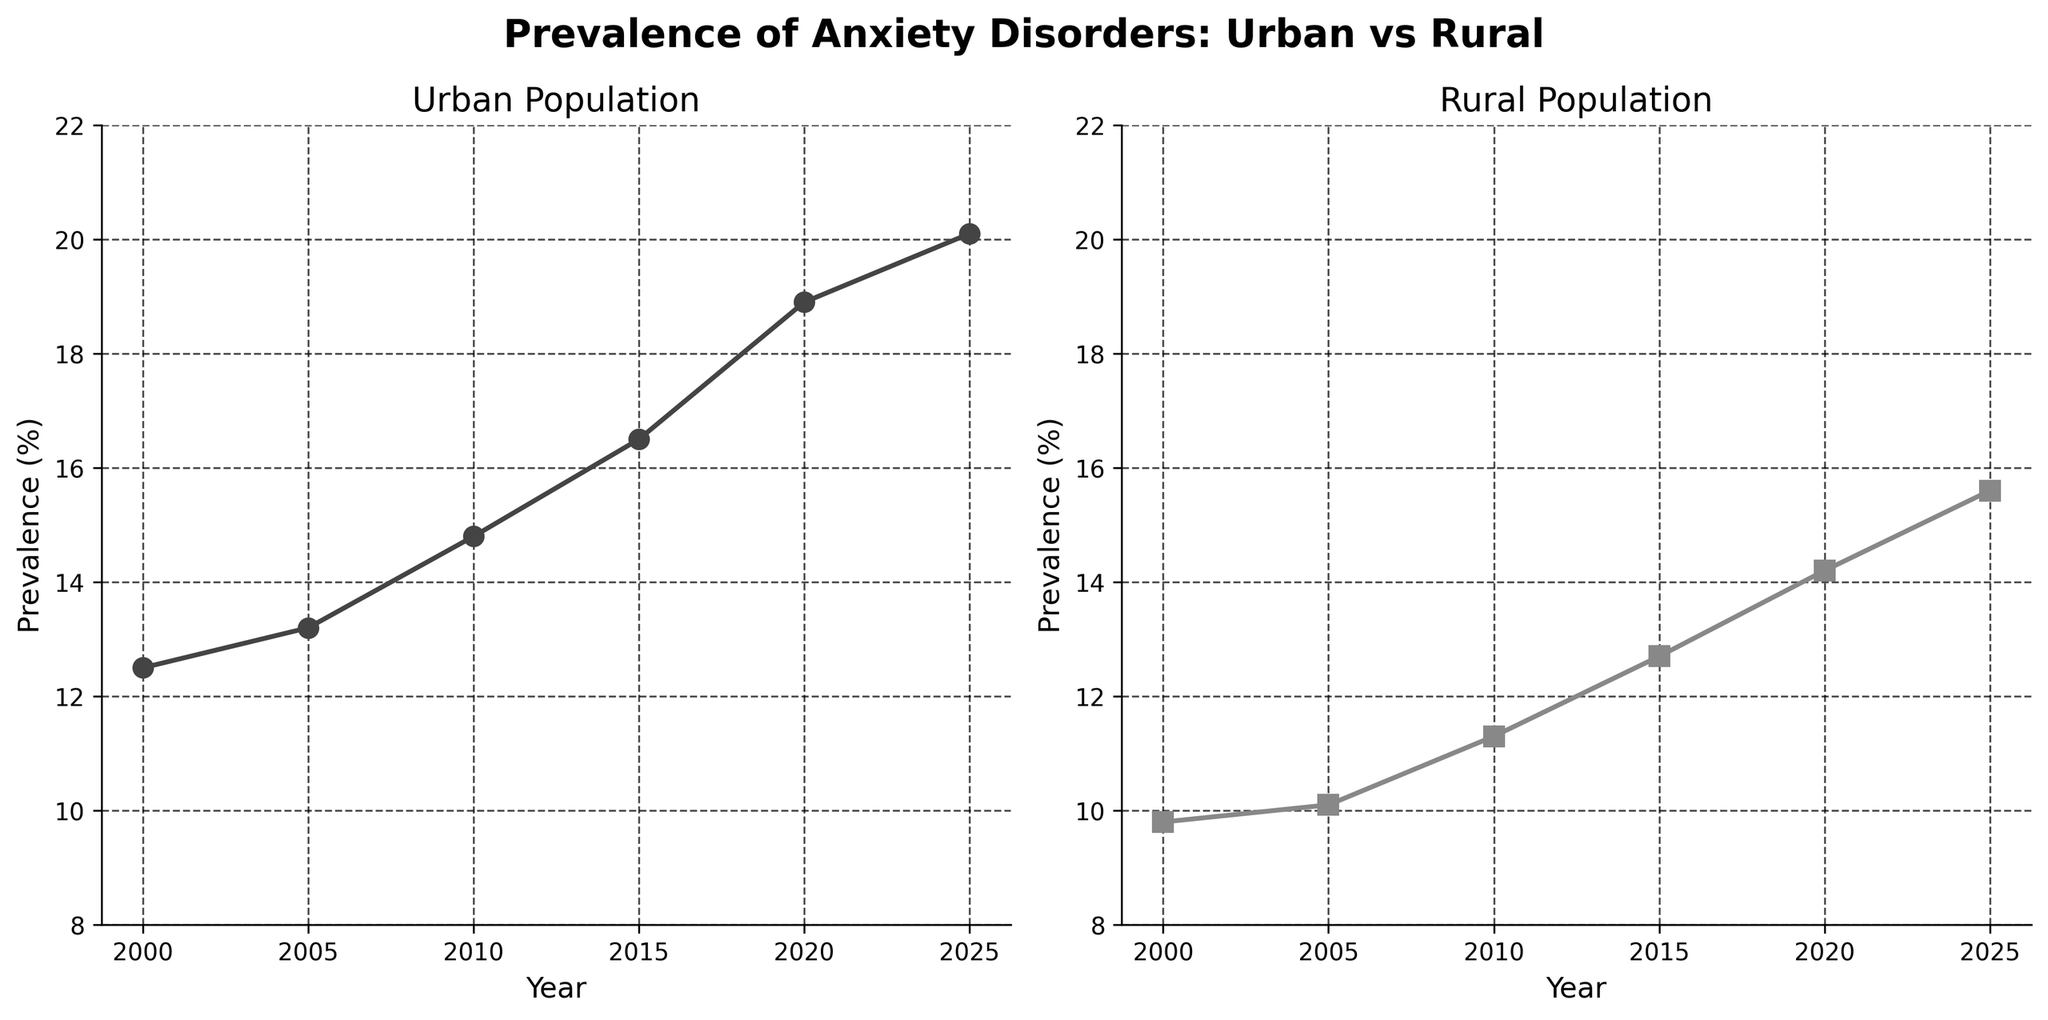What is the title of the figure? The title of the figure is found at the top center of the plot. It reads "Prevalence of Anxiety Disorders: Urban vs Rural".
Answer: Prevalence of Anxiety Disorders: Urban vs Rural What are the x-axis labels in both subplots? The x-axis labels are found at the bottom of each subplot and both read "Year".
Answer: Year Which subplot has a higher prevalence of anxiety disorders in 2015? The prevalence values for 2015 can be read directly from the plots. The Urban Population subplot shows a prevalence of 16.5% while the Rural Population subplot shows 12.7%.
Answer: Urban Population How many data points are represented in each subplot? The data points are marked by symbols on the plots. Counting them, there are 6 data points in each subplot.
Answer: 6 What is the trend of anxiety prevalence in urban populations from 2000 to 2025? The line plot in the Urban Population subplot shows an increasing trend from 12.5% in 2000 to 20.1% in 2025. This indicates a consistently rising trend over the years.
Answer: Increasing What is the difference in anxiety disorder prevalence between urban and rural populations in 2020? The prevalence in 2020 for urban populations is 18.9% and for rural populations is 14.2%. The difference is calculated as 18.9% - 14.2%.
Answer: 4.7% Which population saw a larger absolute increase in anxiety disorders from 2000 to 2025? Calculate the increase for both populations: Urban (20.1% - 12.5% = 7.6%) and Rural (15.6% - 9.8% = 5.8%). The Urban population has a larger absolute increase.
Answer: Urban What is the average prevalence of anxiety disorders in rural populations over the years? Sum the prevalence values for rural population (9.8 + 10.1 + 11.3 + 12.7 + 14.2 + 15.6 = 73.7) and divide by the number of years (6). The average is 73.7 / 6.
Answer: 12.28 During which year did both populations reach the highest and lowest recorded prevalence of anxiety disorders? The highest prevalence for Urban is 20.1% in 2025, and for Rural, it is 15.6% in 2025. The lowest prevalence for Urban is 12.5% in 2000, and for Rural, it is 9.8% in 2000.
Answer: 2025 and 2000 What is the range of anxiety disorder prevalence in the urban population over the years shown? The range is calculated by subtracting the smallest value from the largest value in the Urban Population subplot (20.1% - 12.5%).
Answer: 7.6% 